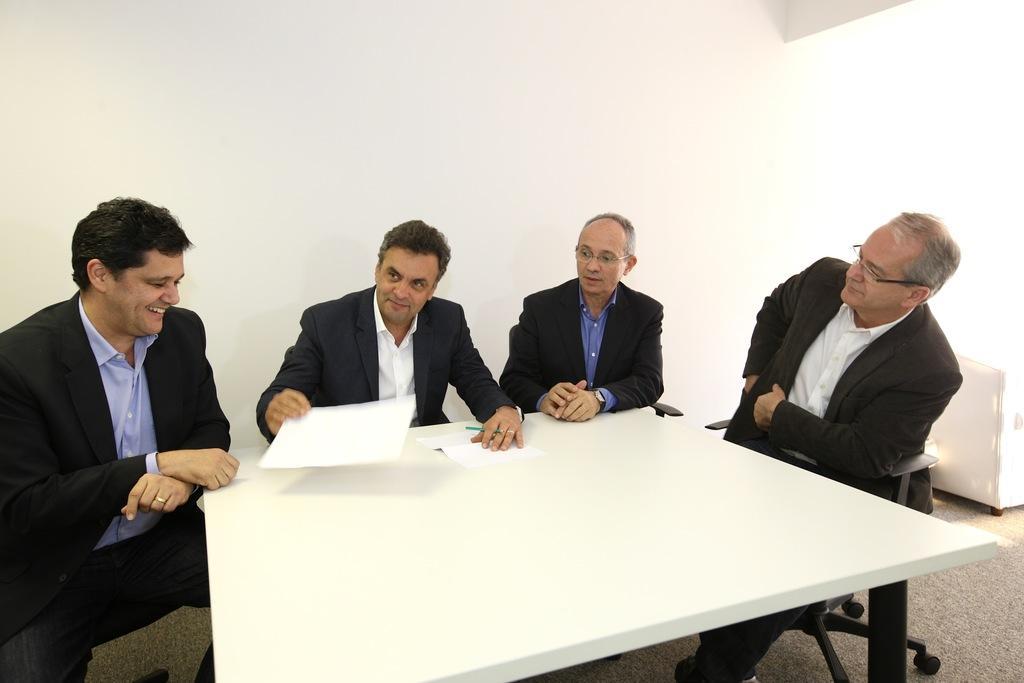Could you give a brief overview of what you see in this image? In this image i can see group of men who are sitting on a chair in front of a white color table. 